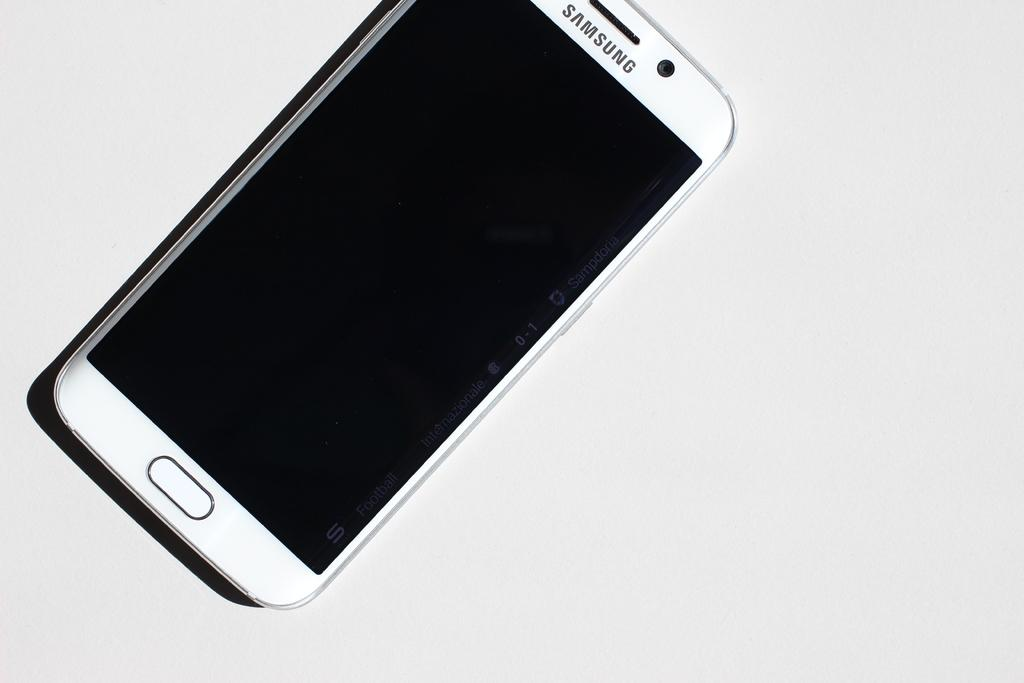<image>
Summarize the visual content of the image. A white Samsung phone with a blank screen is displayed against a white background. 